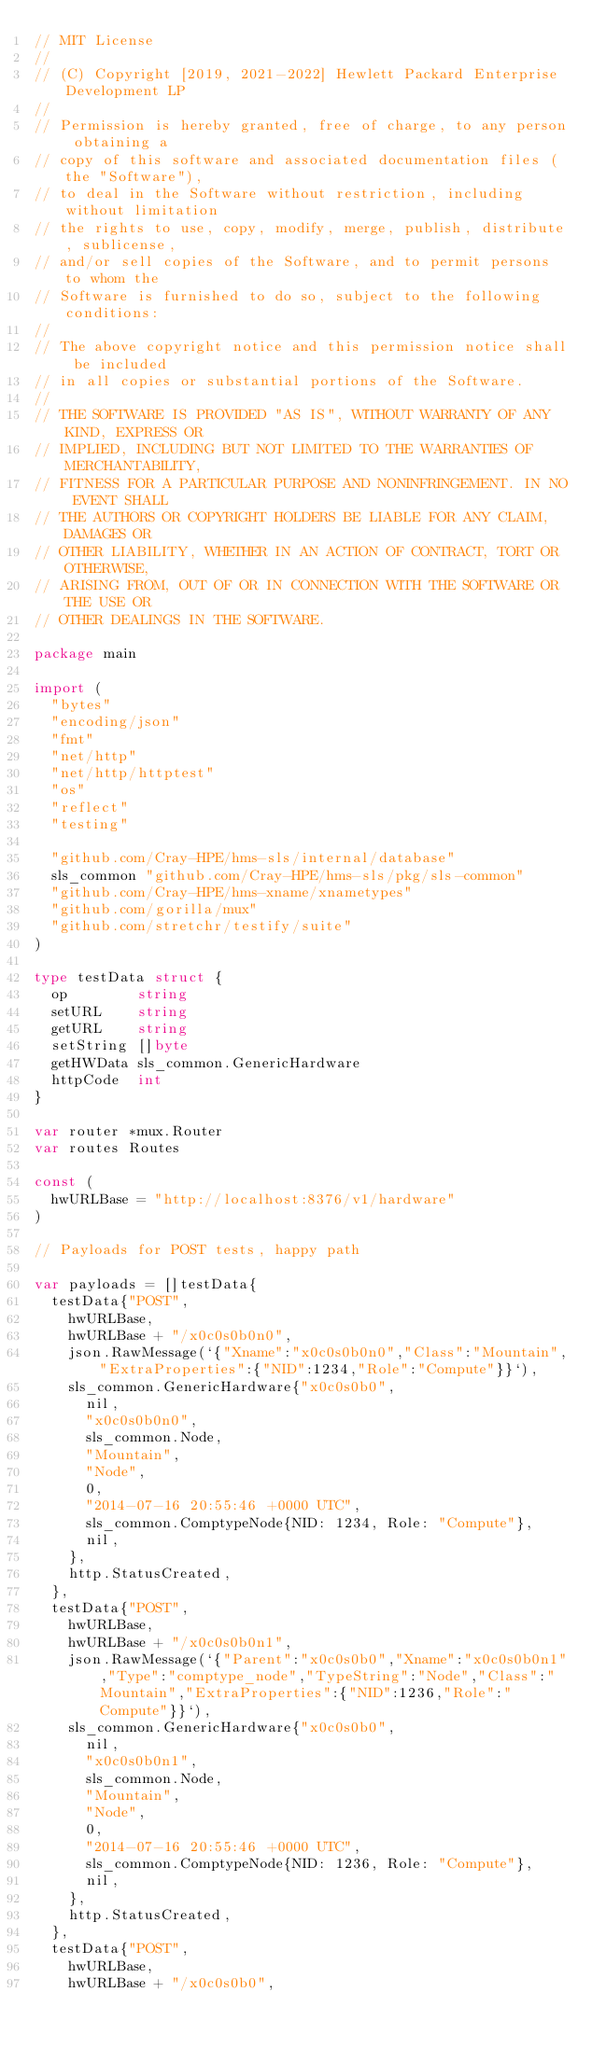Convert code to text. <code><loc_0><loc_0><loc_500><loc_500><_Go_>// MIT License
//
// (C) Copyright [2019, 2021-2022] Hewlett Packard Enterprise Development LP
//
// Permission is hereby granted, free of charge, to any person obtaining a
// copy of this software and associated documentation files (the "Software"),
// to deal in the Software without restriction, including without limitation
// the rights to use, copy, modify, merge, publish, distribute, sublicense,
// and/or sell copies of the Software, and to permit persons to whom the
// Software is furnished to do so, subject to the following conditions:
//
// The above copyright notice and this permission notice shall be included
// in all copies or substantial portions of the Software.
//
// THE SOFTWARE IS PROVIDED "AS IS", WITHOUT WARRANTY OF ANY KIND, EXPRESS OR
// IMPLIED, INCLUDING BUT NOT LIMITED TO THE WARRANTIES OF MERCHANTABILITY,
// FITNESS FOR A PARTICULAR PURPOSE AND NONINFRINGEMENT. IN NO EVENT SHALL
// THE AUTHORS OR COPYRIGHT HOLDERS BE LIABLE FOR ANY CLAIM, DAMAGES OR
// OTHER LIABILITY, WHETHER IN AN ACTION OF CONTRACT, TORT OR OTHERWISE,
// ARISING FROM, OUT OF OR IN CONNECTION WITH THE SOFTWARE OR THE USE OR
// OTHER DEALINGS IN THE SOFTWARE.

package main

import (
	"bytes"
	"encoding/json"
	"fmt"
	"net/http"
	"net/http/httptest"
	"os"
	"reflect"
	"testing"

	"github.com/Cray-HPE/hms-sls/internal/database"
	sls_common "github.com/Cray-HPE/hms-sls/pkg/sls-common"
	"github.com/Cray-HPE/hms-xname/xnametypes"
	"github.com/gorilla/mux"
	"github.com/stretchr/testify/suite"
)

type testData struct {
	op        string
	setURL    string
	getURL    string
	setString []byte
	getHWData sls_common.GenericHardware
	httpCode  int
}

var router *mux.Router
var routes Routes

const (
	hwURLBase = "http://localhost:8376/v1/hardware"
)

// Payloads for POST tests, happy path

var payloads = []testData{
	testData{"POST",
		hwURLBase,
		hwURLBase + "/x0c0s0b0n0",
		json.RawMessage(`{"Xname":"x0c0s0b0n0","Class":"Mountain","ExtraProperties":{"NID":1234,"Role":"Compute"}}`),
		sls_common.GenericHardware{"x0c0s0b0",
			nil,
			"x0c0s0b0n0",
			sls_common.Node,
			"Mountain",
			"Node",
			0,
			"2014-07-16 20:55:46 +0000 UTC",
			sls_common.ComptypeNode{NID: 1234, Role: "Compute"},
			nil,
		},
		http.StatusCreated,
	},
	testData{"POST",
		hwURLBase,
		hwURLBase + "/x0c0s0b0n1",
		json.RawMessage(`{"Parent":"x0c0s0b0","Xname":"x0c0s0b0n1","Type":"comptype_node","TypeString":"Node","Class":"Mountain","ExtraProperties":{"NID":1236,"Role":"Compute"}}`),
		sls_common.GenericHardware{"x0c0s0b0",
			nil,
			"x0c0s0b0n1",
			sls_common.Node,
			"Mountain",
			"Node",
			0,
			"2014-07-16 20:55:46 +0000 UTC",
			sls_common.ComptypeNode{NID: 1236, Role: "Compute"},
			nil,
		},
		http.StatusCreated,
	},
	testData{"POST",
		hwURLBase,
		hwURLBase + "/x0c0s0b0",</code> 